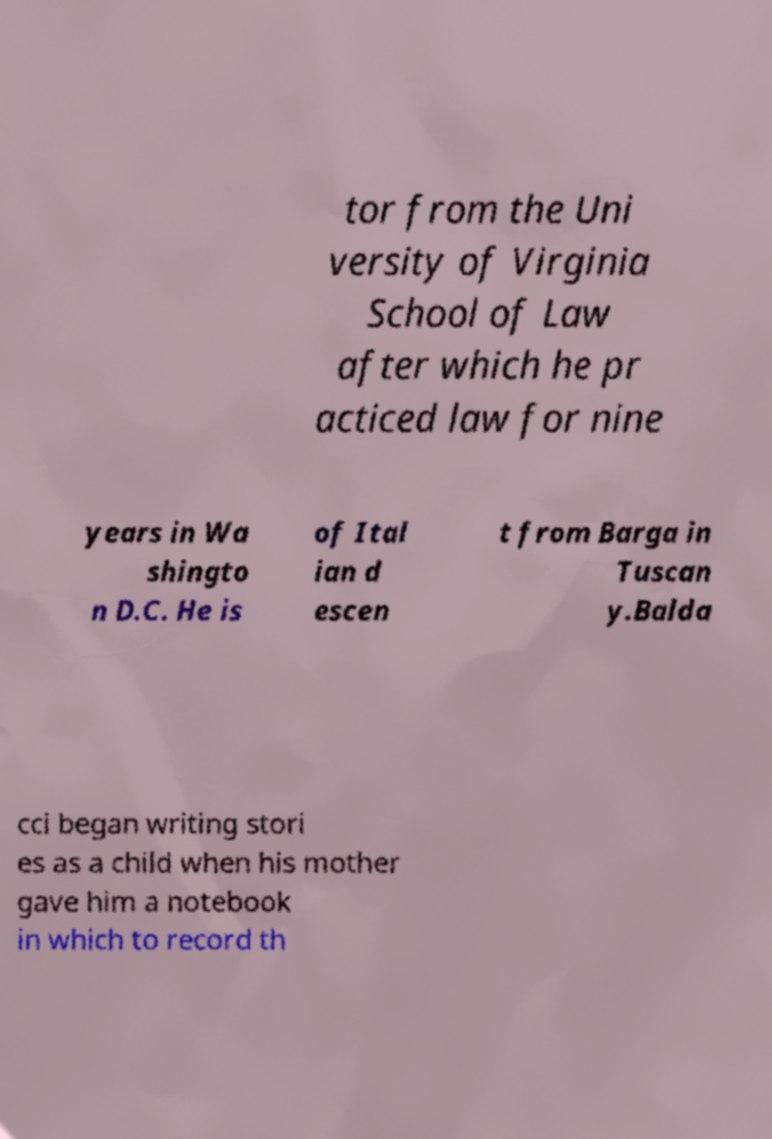For documentation purposes, I need the text within this image transcribed. Could you provide that? tor from the Uni versity of Virginia School of Law after which he pr acticed law for nine years in Wa shingto n D.C. He is of Ital ian d escen t from Barga in Tuscan y.Balda cci began writing stori es as a child when his mother gave him a notebook in which to record th 